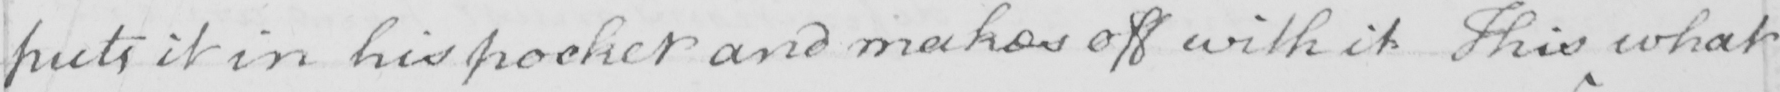Please transcribe the handwritten text in this image. puts it in his pocket and makes off with it . This what 